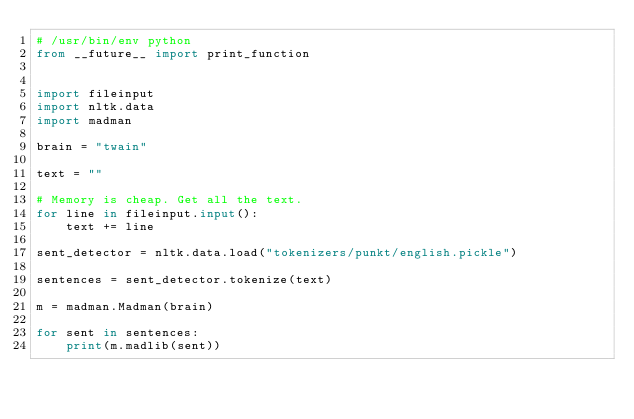Convert code to text. <code><loc_0><loc_0><loc_500><loc_500><_Python_># /usr/bin/env python
from __future__ import print_function


import fileinput
import nltk.data
import madman

brain = "twain"

text = ""

# Memory is cheap. Get all the text.
for line in fileinput.input():
    text += line

sent_detector = nltk.data.load("tokenizers/punkt/english.pickle")

sentences = sent_detector.tokenize(text)

m = madman.Madman(brain)

for sent in sentences:
    print(m.madlib(sent))
</code> 